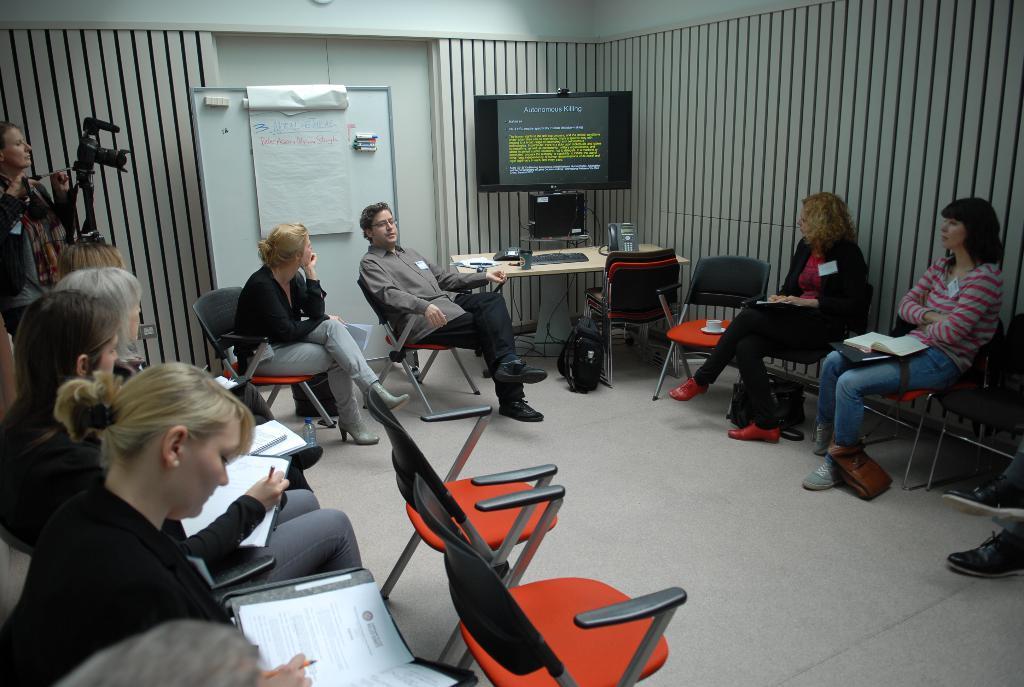How would you summarize this image in a sentence or two? On the right there are two women sitting on the chairs. In the middle there is a tel vision ,table ,tel phone ,keyboard and chair. On the left there is a woman with camera. In the middle there are two persons ,white board and chairs. 